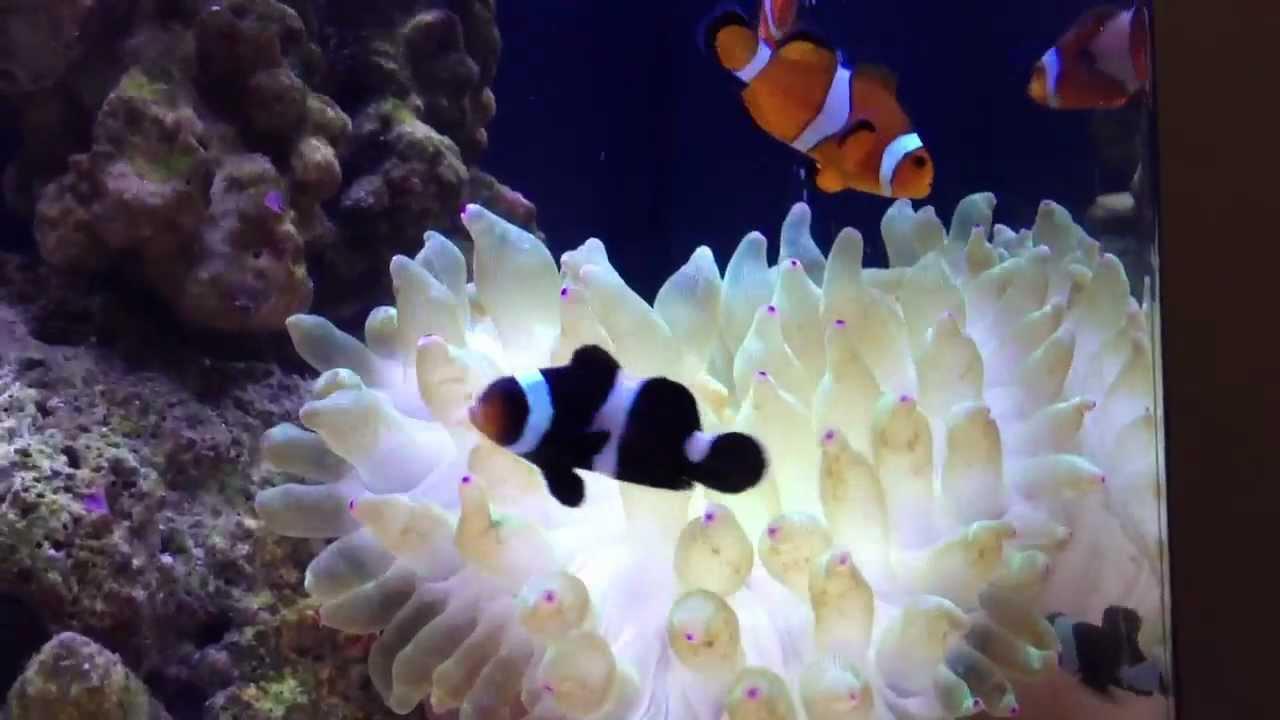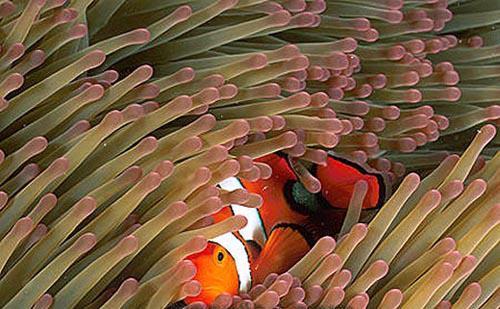The first image is the image on the left, the second image is the image on the right. Considering the images on both sides, is "One image shows two fish in anemone tendrils that emerge from a dark-orangish """"stalk""""." valid? Answer yes or no. No. 